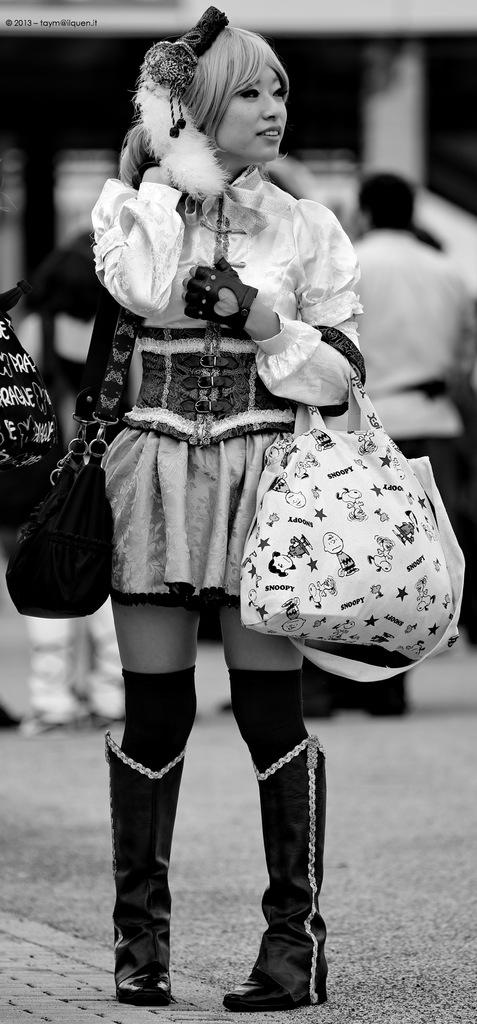What is the woman in the image doing? The woman is standing in the image. What is the woman holding in the image? The woman is holding two bags. Can you describe the background of the image? There are there any other people present? What type of rice is being cooked in the rainstorm in the image? There is no rice or rainstorm present in the image. The image features a woman standing with two bags and people in the background. 